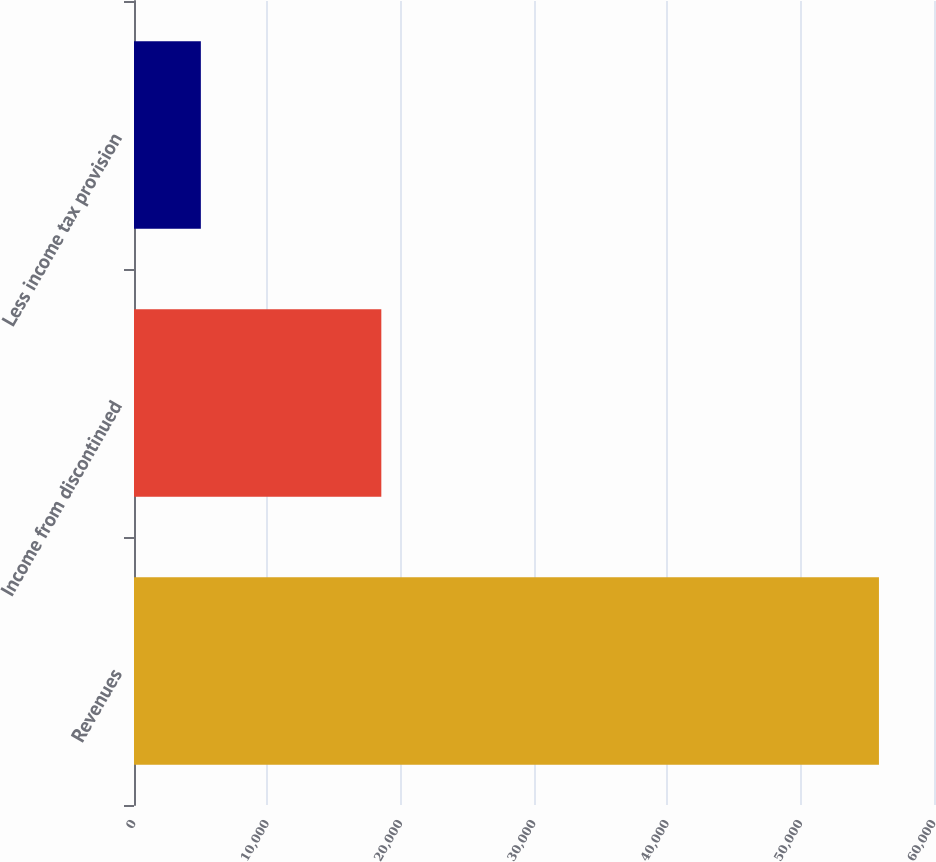Convert chart. <chart><loc_0><loc_0><loc_500><loc_500><bar_chart><fcel>Revenues<fcel>Income from discontinued<fcel>Less income tax provision<nl><fcel>55871<fcel>18549<fcel>5014<nl></chart> 